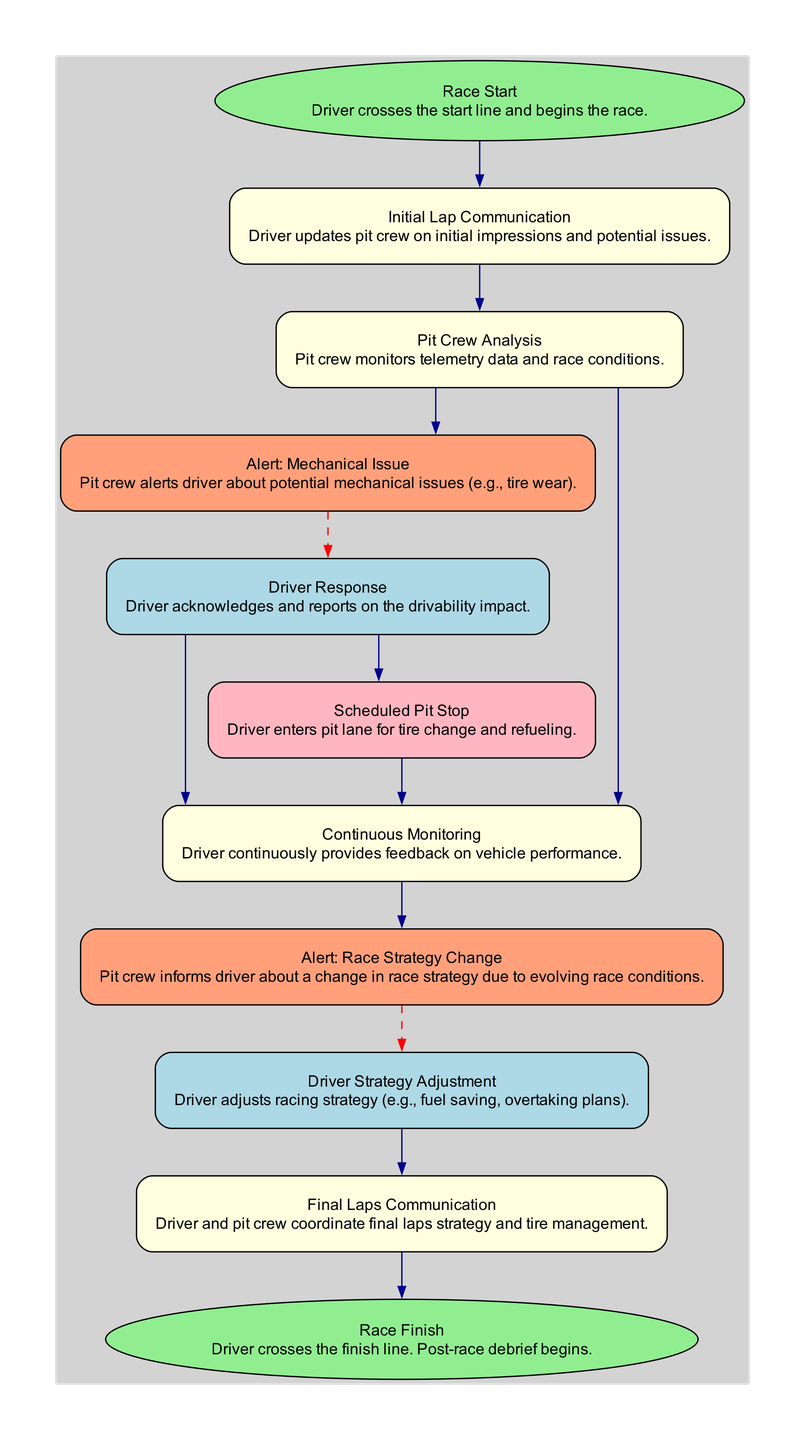What's the first action taken in the diagram? The diagram starts with the node labeled "Race Start," which indicates that the driver crosses the start line and begins the race. This is the initial action before any communication takes place.
Answer: Race Start How many nodes are there in total? By counting each distinct element in the diagram, we find there are 10 nodes: Race Start, Initial Lap Communication, Pit Crew Analysis, Alert: Mechanical Issue, Driver Response, Scheduled Pit Stop, Continuous Monitoring, Alert: Race Strategy Change, Driver Strategy Adjustment, Final Laps Communication, and Race Finish.
Answer: 11 Which node provides feedback on vehicle performance? The node "Continuous Monitoring" specifically describes the action where the driver provides continuous feedback on vehicle performance, making it the answer.
Answer: Continuous Monitoring What happens after the driver acknowledges a mechanical issue? Following the driver’s acknowledgment of the mechanical issue in "Driver Response," there are two possible paths: the driver may enter a "Scheduled Pit Stop" for tire change and refueling, or continue without stopping, leading to "Continuous Monitoring."
Answer: Driver may enter Scheduled Pit Stop or continue to Continuous Monitoring What indicates a change in race strategy? The node labeled "Alert: Race Strategy Change" explicitly informs the driver about alterations in race strategy due to evolving conditions, making it the point of indication.
Answer: Alert: Race Strategy Change How does the flow proceed after the final laps communication? The final laps communication is followed by the node "Race Finish," indicating that after coordinating strategy and tire management, the race concludes when the driver crosses the finish line.
Answer: Race Finish What is the color scheme for nodes related to alerts? Nodes associated with alerts are colored in lightsalmon, as indicated in the diagram's design. This is distinct from other categories of nodes which use different colors.
Answer: Lightsalmon What is the response taken after receiving an alert about a mechanical issue? The response to the "Alert: Mechanical Issue" is the node labeled "Driver Response," where the driver acknowledges the alert and reports the impact on drivability, detailing the communication process.
Answer: Driver Response What is the final outcome of the race process described? The process concludes with the node "Race Finish," marking the end of the race when the driver completes the final lap and crosses the finish line.
Answer: Race Finish 